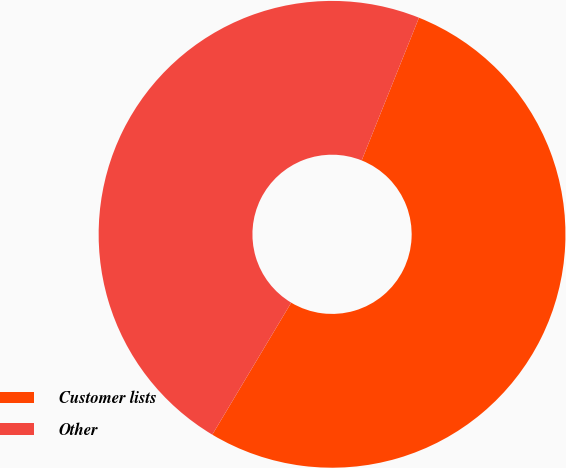Convert chart to OTSL. <chart><loc_0><loc_0><loc_500><loc_500><pie_chart><fcel>Customer lists<fcel>Other<nl><fcel>52.5%<fcel>47.5%<nl></chart> 